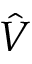Convert formula to latex. <formula><loc_0><loc_0><loc_500><loc_500>\hat { V }</formula> 